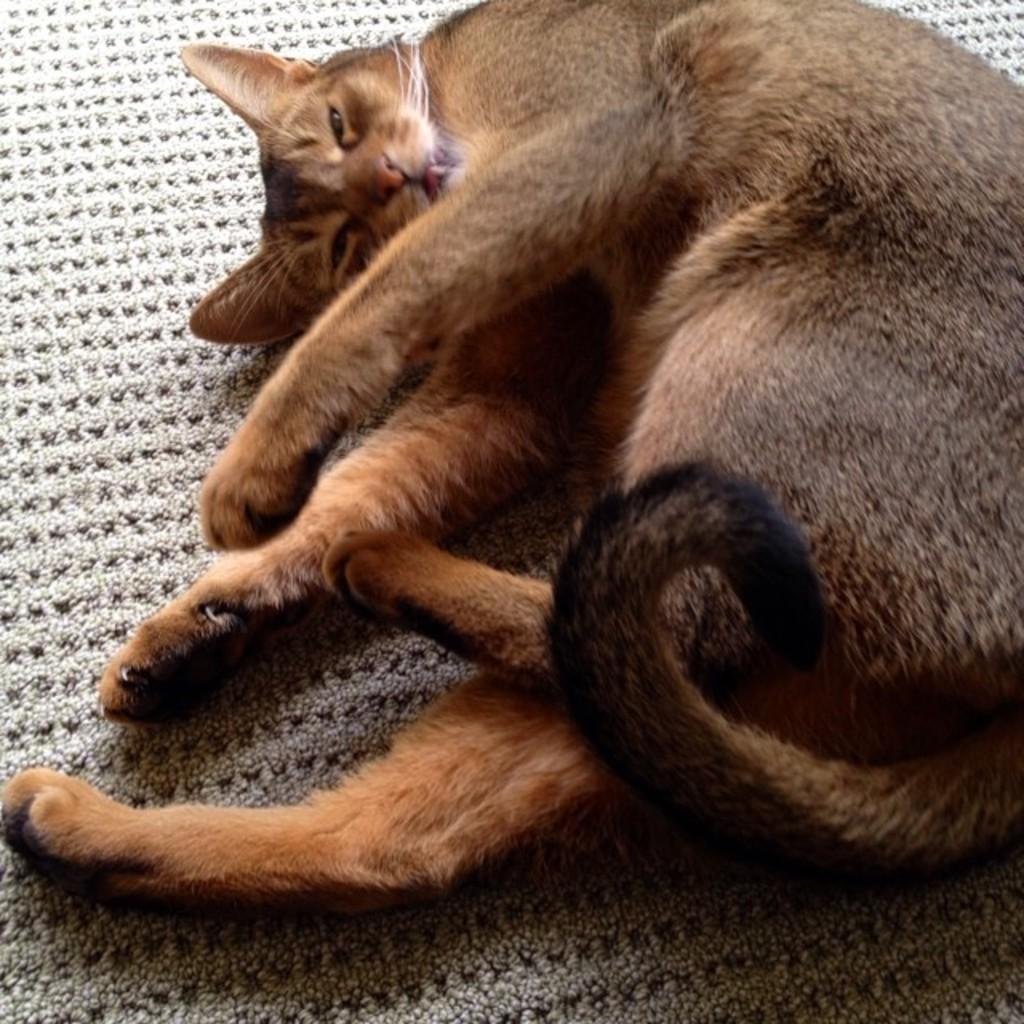In one or two sentences, can you explain what this image depicts? In this image we can see a cat sleeping on the mat. 